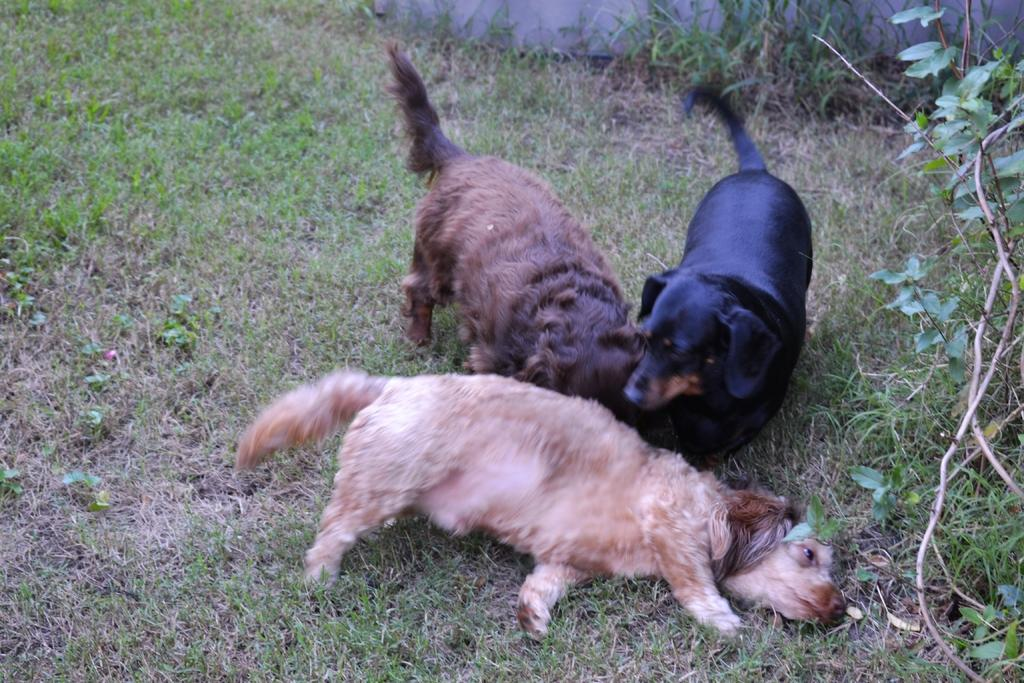How many puppies are in the image? There are three small puppies in the image. What are the puppies doing in the image? The puppies are laying on the grass. What can be seen around the puppies? There are small plants around the puppies. What colors are the puppies? The puppies are of brown, black, and cream color. What type of cherries are hanging from the bushes in the image? There are no bushes or cherries present in the image; it features three small puppies laying on the grass with small plants around them. 